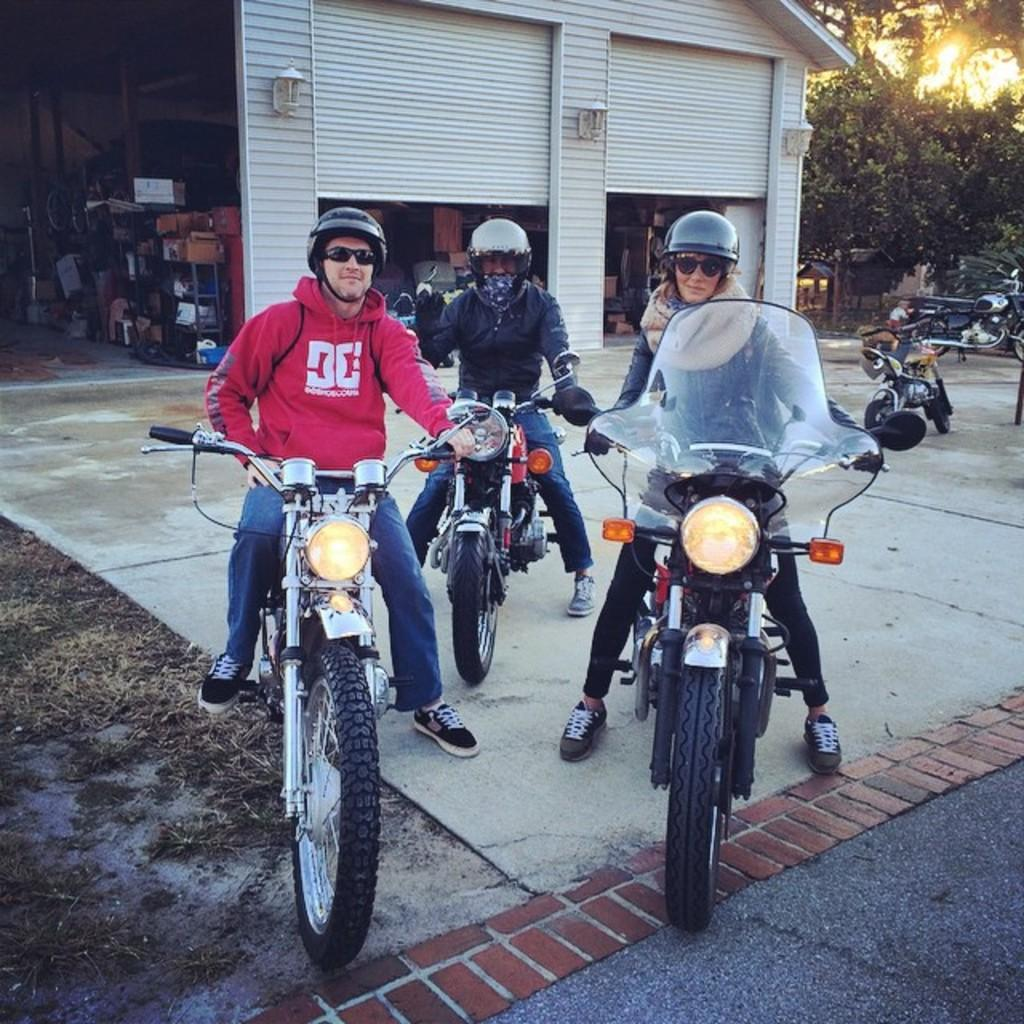How many people are in the image? There are three persons in the image. What are the persons doing in the image? The persons are riding bikes. Where are the bikes located? The bikes are on a road. What can be seen in the background of the image? There is a building, a light, and a tree in the background of the image. What song is being sung by the persons in the image? There is no indication in the image that the persons are singing a song. 